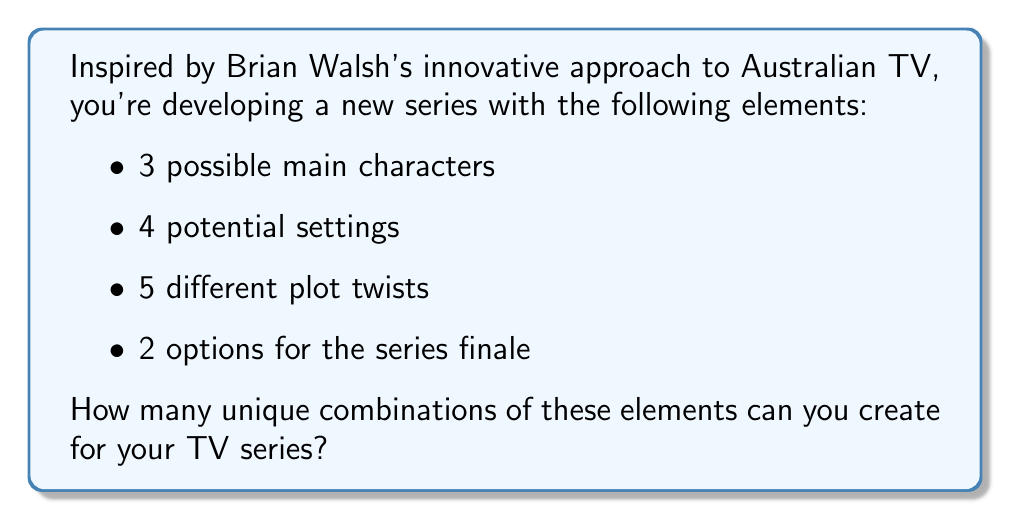Can you answer this question? Let's approach this step-by-step using the multiplication principle of combinatorics:

1) For each element, we have independent choices:
   - Main characters: 3 options
   - Settings: 4 options
   - Plot twists: 5 options
   - Series finale: 2 options

2) According to the multiplication principle, if we have a series of independent choices, the total number of possibilities is the product of the number of possibilities for each choice.

3) Therefore, the total number of unique combinations is:

   $$ \text{Total combinations} = 3 \times 4 \times 5 \times 2 $$

4) Let's calculate:
   $$ 3 \times 4 \times 5 \times 2 = 12 \times 5 \times 2 = 60 \times 2 = 120 $$

Thus, there are 120 unique combinations possible for your TV series.
Answer: 120 